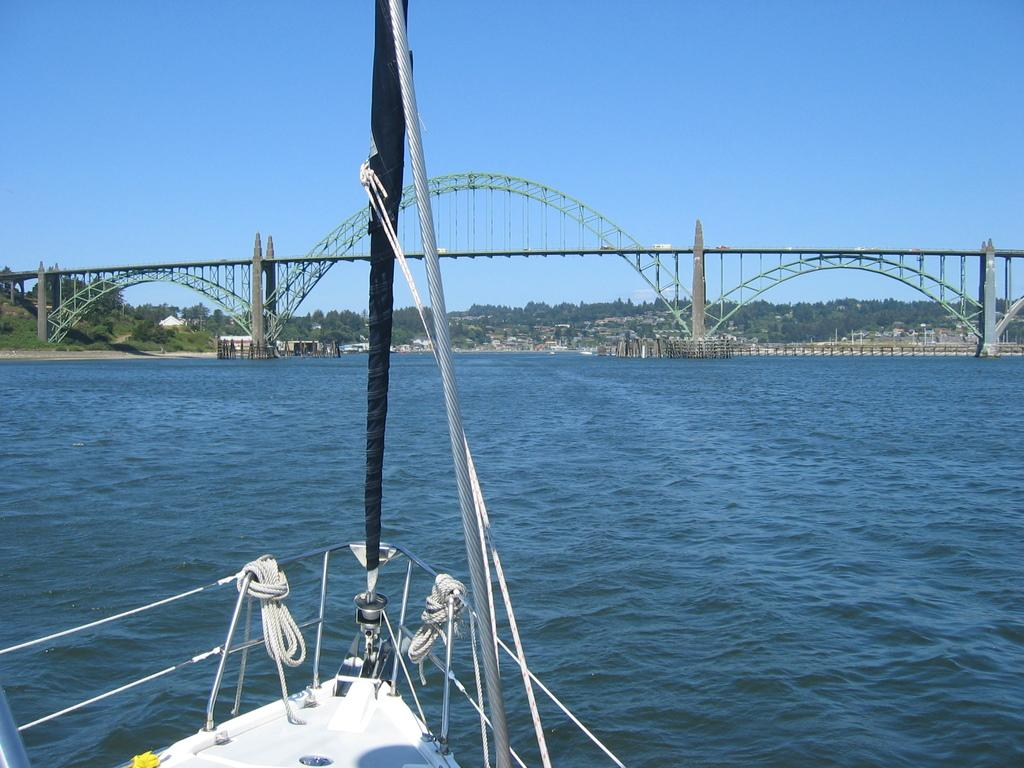What is the main feature in the image? There is a water body in the image. What is located in the foreground of the image? There is a boat in the foreground of the image. What can be seen in the background of the image? There is a bridge, trees, buildings, and the sky visible in the background of the image. What position are the hands of the trees in the image? Trees do not have hands, so this question cannot be answered based on the image. 